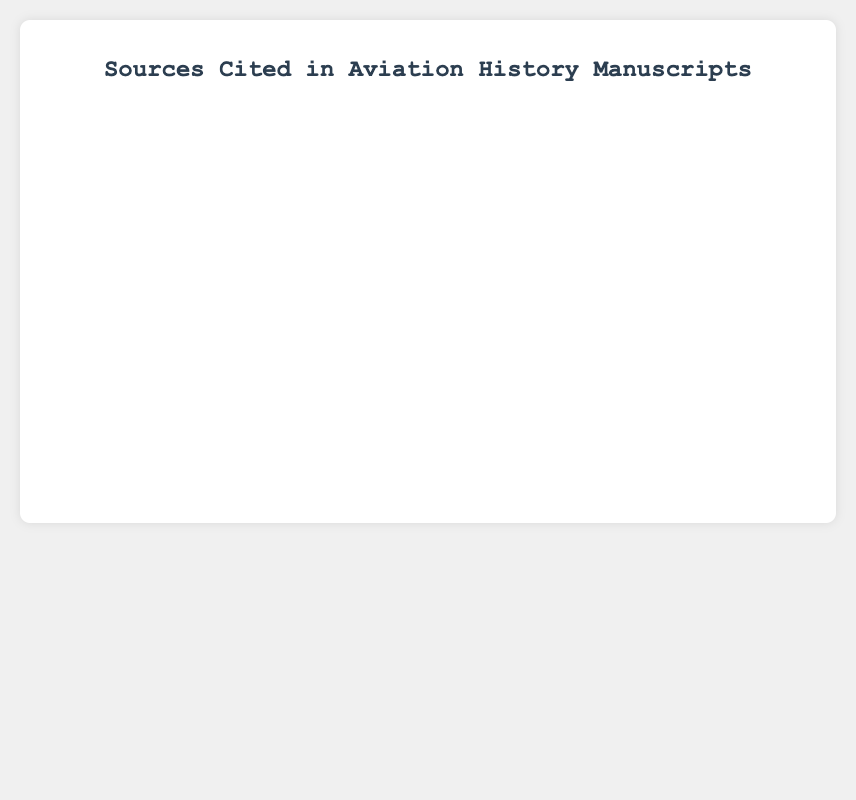Which source is cited the most? From the chart, the highest bar represents "Government Records" with 45 citations.
Answer: Government Records What is the total number of citations for all sources combined? Sum the citation counts for all sources: 45 (Government Records) + 30 (Firsthand Accounts) + 25 (Technical Manuals) + 20 (Newspapers) + 15 (Journals) + 35 (Books) + 10 (Photographs) + 18 (Aircraft Maintenance Logs) + 12 (Pilot Logs) = 210.
Answer: 210 Which source has more citations: Technical Manuals or Newspapers? From the chart, "Technical Manuals" have 25 citations, whereas "Newspapers" have 20.
Answer: Technical Manuals How many more citations do Books have compared to Pilot Logs? Books have 35 citations, and Pilot Logs have 12. The difference is 35 - 12 = 23.
Answer: 23 What is the median number of citations among all sources listed? Arrange the citation counts in ascending order: 10, 12, 15, 18, 20, 25, 30, 35, 45. The median citation count (the middle value) is 25.
Answer: 25 Which sources have fewer than 20 citations each? According to the chart: Journals (15), Photographs (10), Aircraft Maintenance Logs (18), and Pilot Logs (12) have fewer than 20 citations.
Answer: Journals, Photographs, Aircraft Maintenance Logs, Pilot Logs What is the sum of citations for Firsthand Accounts and Books? Firsthand Accounts have 30 citations, and Books have 35. The sum is 30 + 35 = 65.
Answer: 65 Which source stands out visually by color on the chart? The color for "Government Records" is visually prominent with a bright blue, indicating it stands out the most in the chart.
Answer: Government Records 